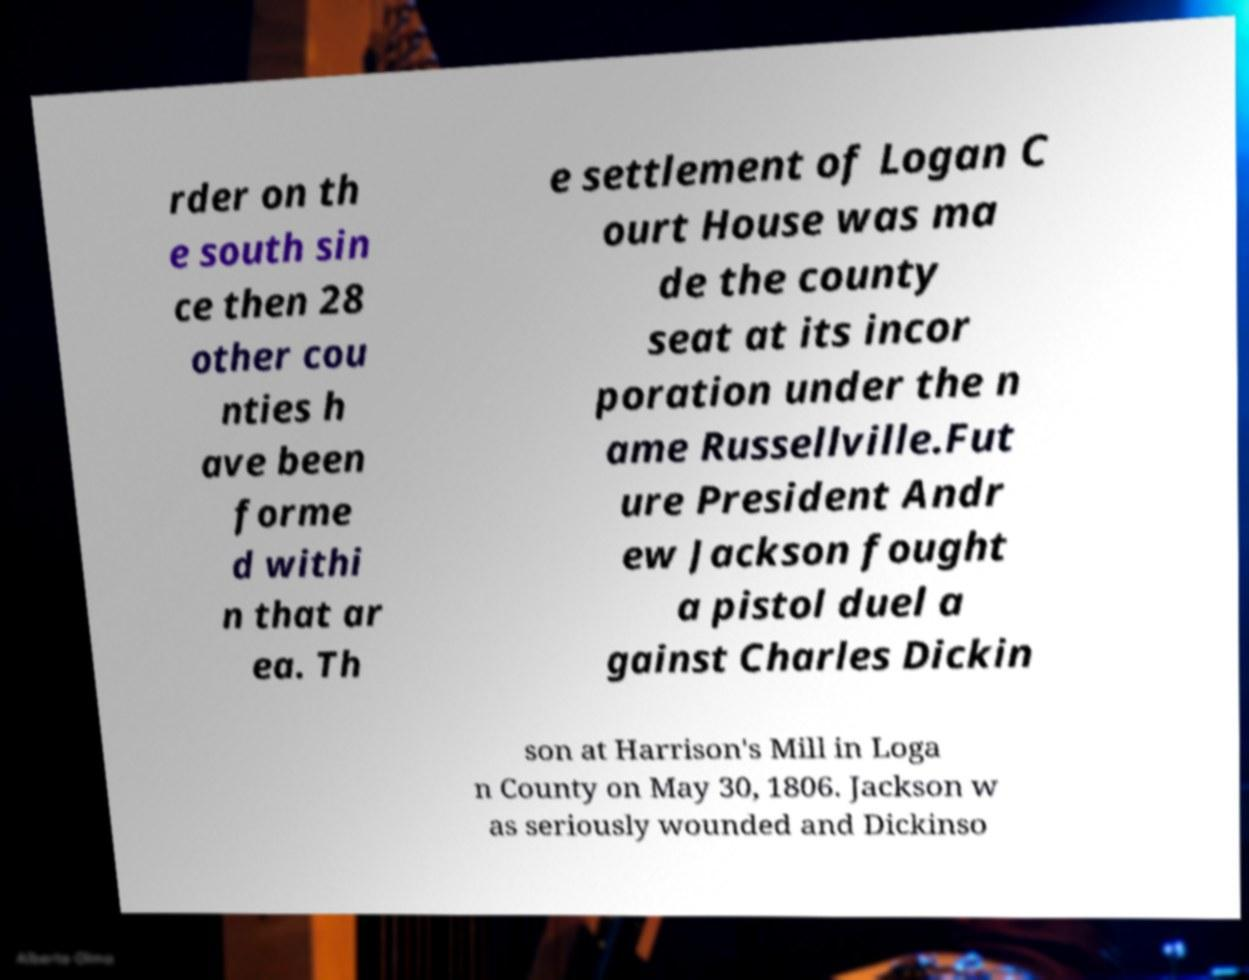There's text embedded in this image that I need extracted. Can you transcribe it verbatim? rder on th e south sin ce then 28 other cou nties h ave been forme d withi n that ar ea. Th e settlement of Logan C ourt House was ma de the county seat at its incor poration under the n ame Russellville.Fut ure President Andr ew Jackson fought a pistol duel a gainst Charles Dickin son at Harrison's Mill in Loga n County on May 30, 1806. Jackson w as seriously wounded and Dickinso 